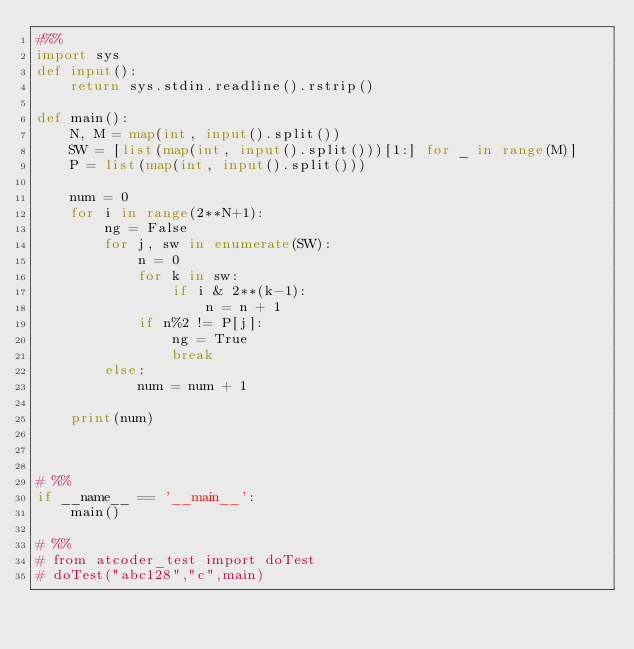<code> <loc_0><loc_0><loc_500><loc_500><_Python_>#%%
import sys
def input():
    return sys.stdin.readline().rstrip()

def main():
    N, M = map(int, input().split())
    SW = [list(map(int, input().split()))[1:] for _ in range(M)]
    P = list(map(int, input().split()))

    num = 0
    for i in range(2**N+1):
        ng = False
        for j, sw in enumerate(SW):
            n = 0
            for k in sw:
                if i & 2**(k-1):
                    n = n + 1
            if n%2 != P[j]:
                ng = True
                break
        else:
            num = num + 1
    
    print(num)



# %%
if __name__ == '__main__':
    main()

# %%
# from atcoder_test import doTest
# doTest("abc128","c",main)</code> 